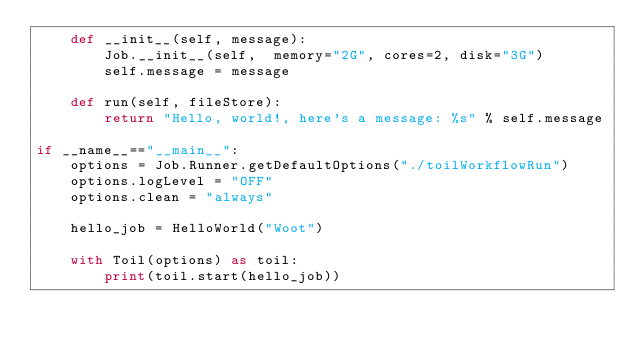Convert code to text. <code><loc_0><loc_0><loc_500><loc_500><_Python_>    def __init__(self, message):
        Job.__init__(self,  memory="2G", cores=2, disk="3G")
        self.message = message

    def run(self, fileStore):
        return "Hello, world!, here's a message: %s" % self.message

if __name__=="__main__":
    options = Job.Runner.getDefaultOptions("./toilWorkflowRun")
    options.logLevel = "OFF"
    options.clean = "always"

    hello_job = HelloWorld("Woot")

    with Toil(options) as toil:
        print(toil.start(hello_job))
</code> 